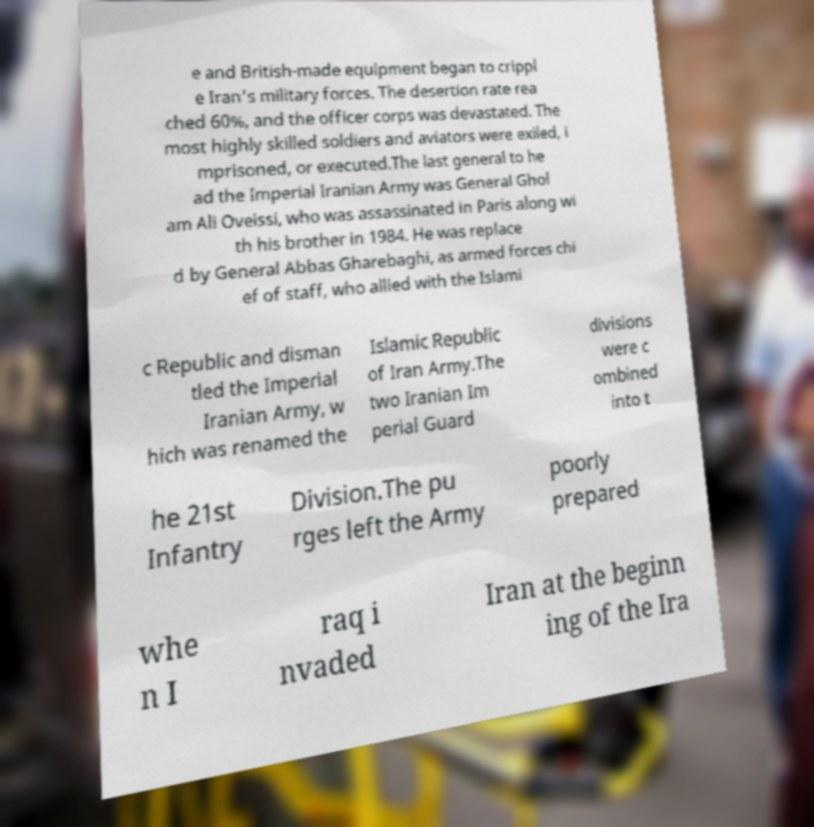Can you accurately transcribe the text from the provided image for me? e and British-made equipment began to crippl e Iran's military forces. The desertion rate rea ched 60%, and the officer corps was devastated. The most highly skilled soldiers and aviators were exiled, i mprisoned, or executed.The last general to he ad the Imperial Iranian Army was General Ghol am Ali Oveissi, who was assassinated in Paris along wi th his brother in 1984. He was replace d by General Abbas Gharebaghi, as armed forces chi ef of staff, who allied with the Islami c Republic and disman tled the Imperial Iranian Army, w hich was renamed the Islamic Republic of Iran Army.The two Iranian Im perial Guard divisions were c ombined into t he 21st Infantry Division.The pu rges left the Army poorly prepared whe n I raq i nvaded Iran at the beginn ing of the Ira 